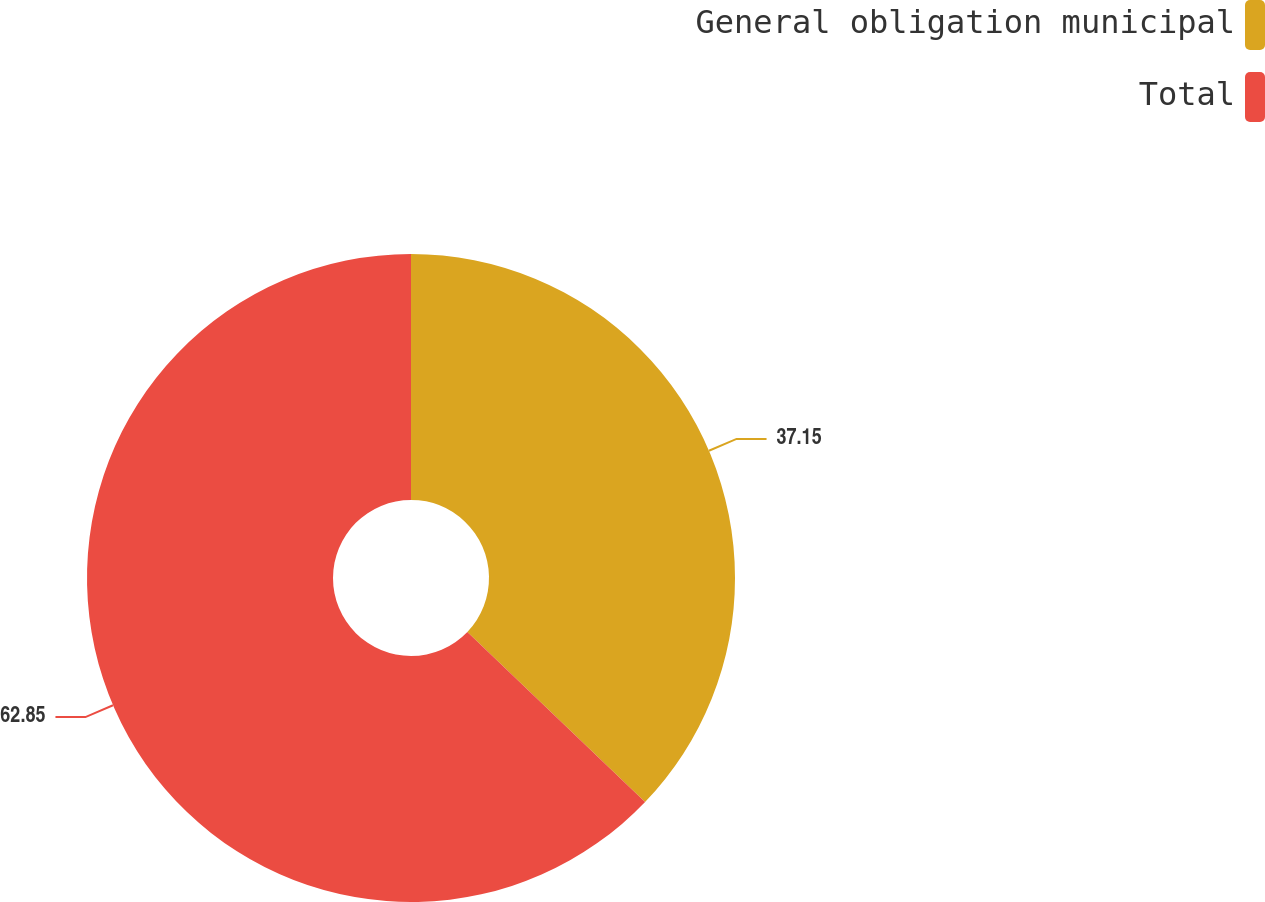Convert chart to OTSL. <chart><loc_0><loc_0><loc_500><loc_500><pie_chart><fcel>General obligation municipal<fcel>Total<nl><fcel>37.15%<fcel>62.85%<nl></chart> 